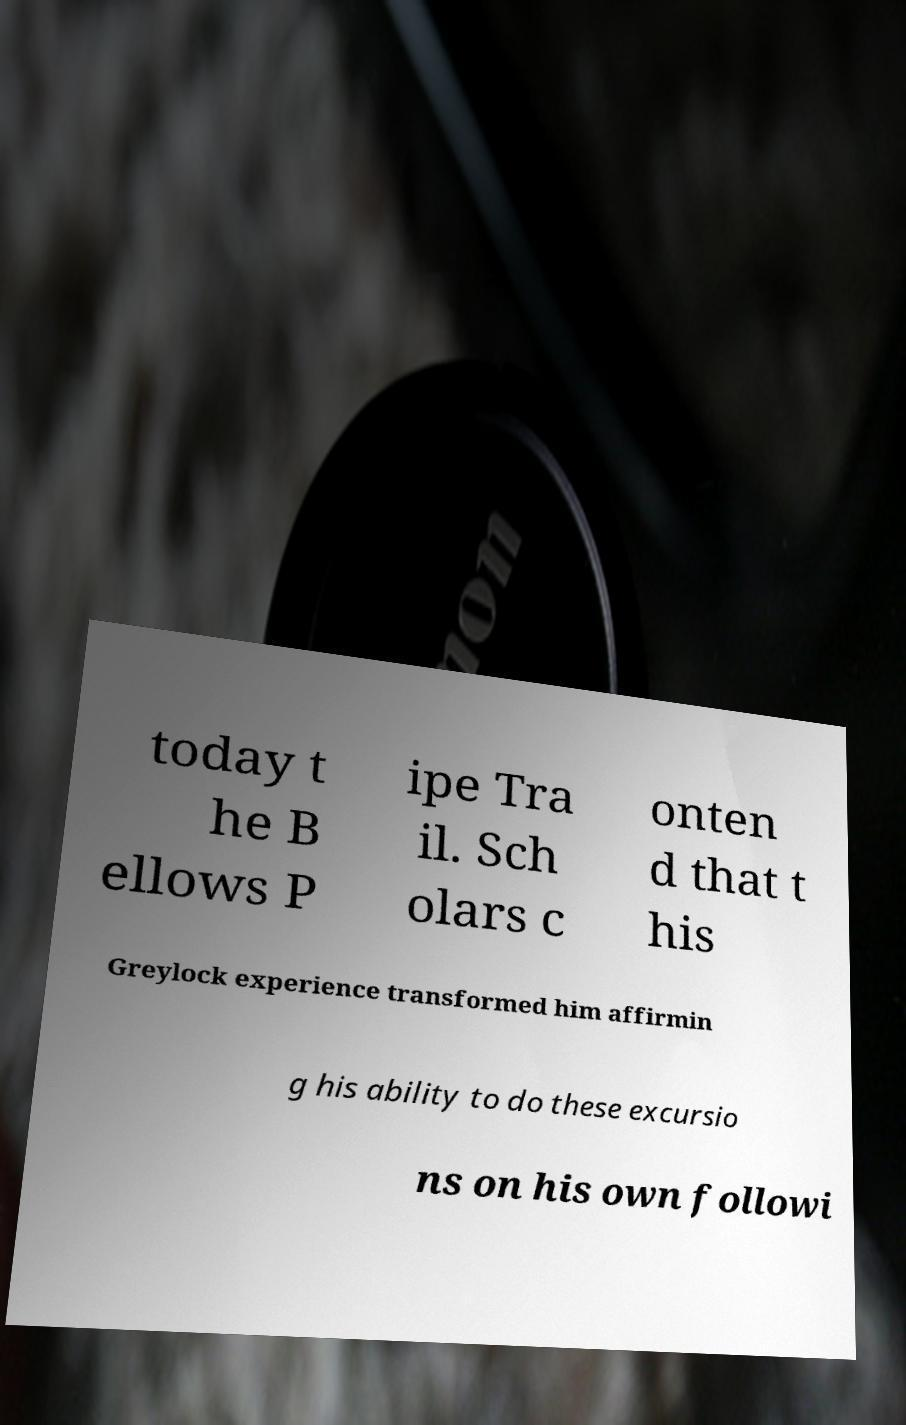Could you extract and type out the text from this image? today t he B ellows P ipe Tra il. Sch olars c onten d that t his Greylock experience transformed him affirmin g his ability to do these excursio ns on his own followi 